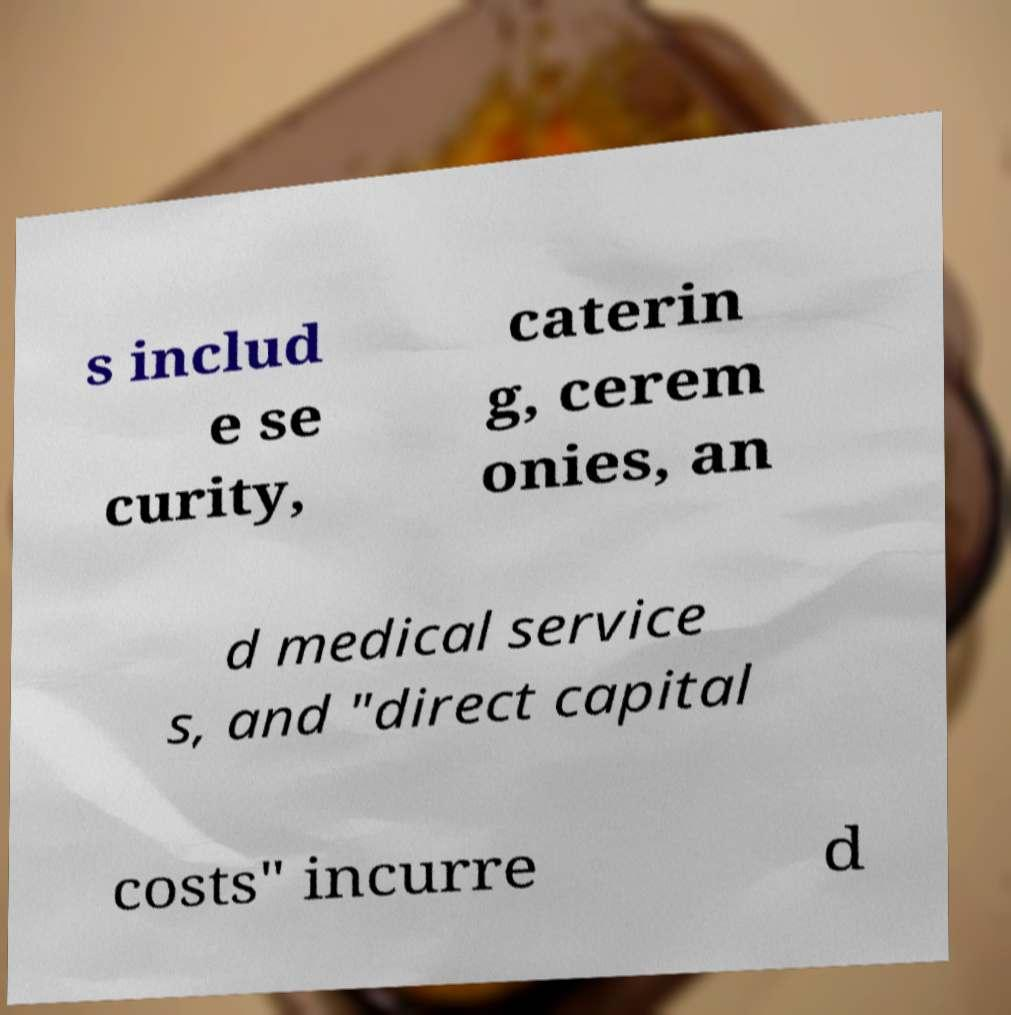There's text embedded in this image that I need extracted. Can you transcribe it verbatim? s includ e se curity, caterin g, cerem onies, an d medical service s, and "direct capital costs" incurre d 